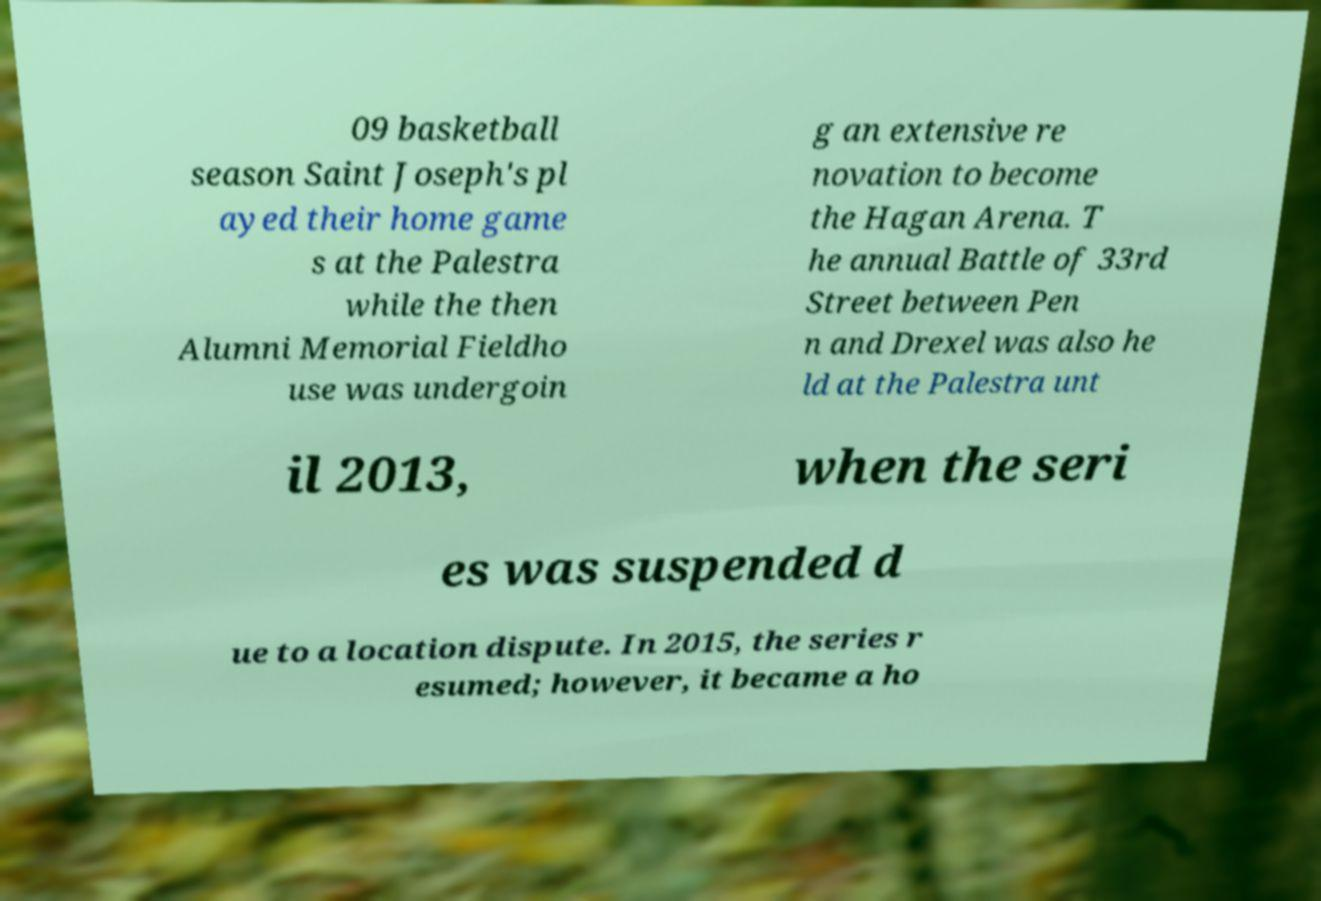For documentation purposes, I need the text within this image transcribed. Could you provide that? 09 basketball season Saint Joseph's pl ayed their home game s at the Palestra while the then Alumni Memorial Fieldho use was undergoin g an extensive re novation to become the Hagan Arena. T he annual Battle of 33rd Street between Pen n and Drexel was also he ld at the Palestra unt il 2013, when the seri es was suspended d ue to a location dispute. In 2015, the series r esumed; however, it became a ho 